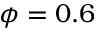Convert formula to latex. <formula><loc_0><loc_0><loc_500><loc_500>\phi = 0 . 6</formula> 